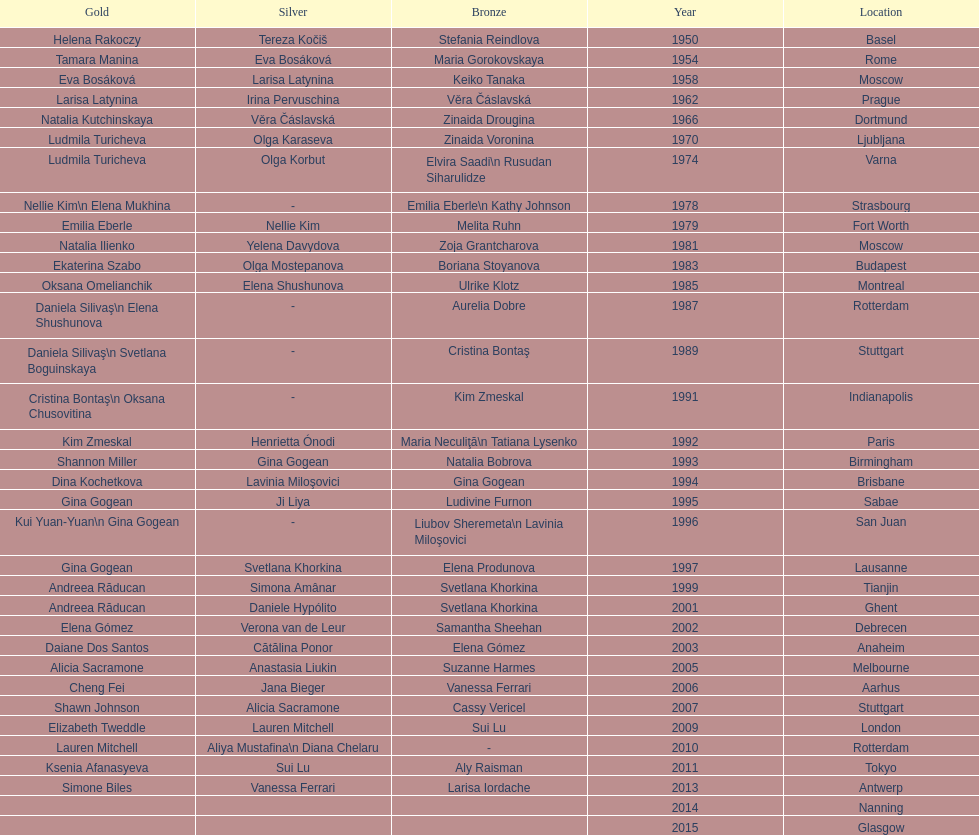What is the number of times a brazilian has won a medal? 2. 